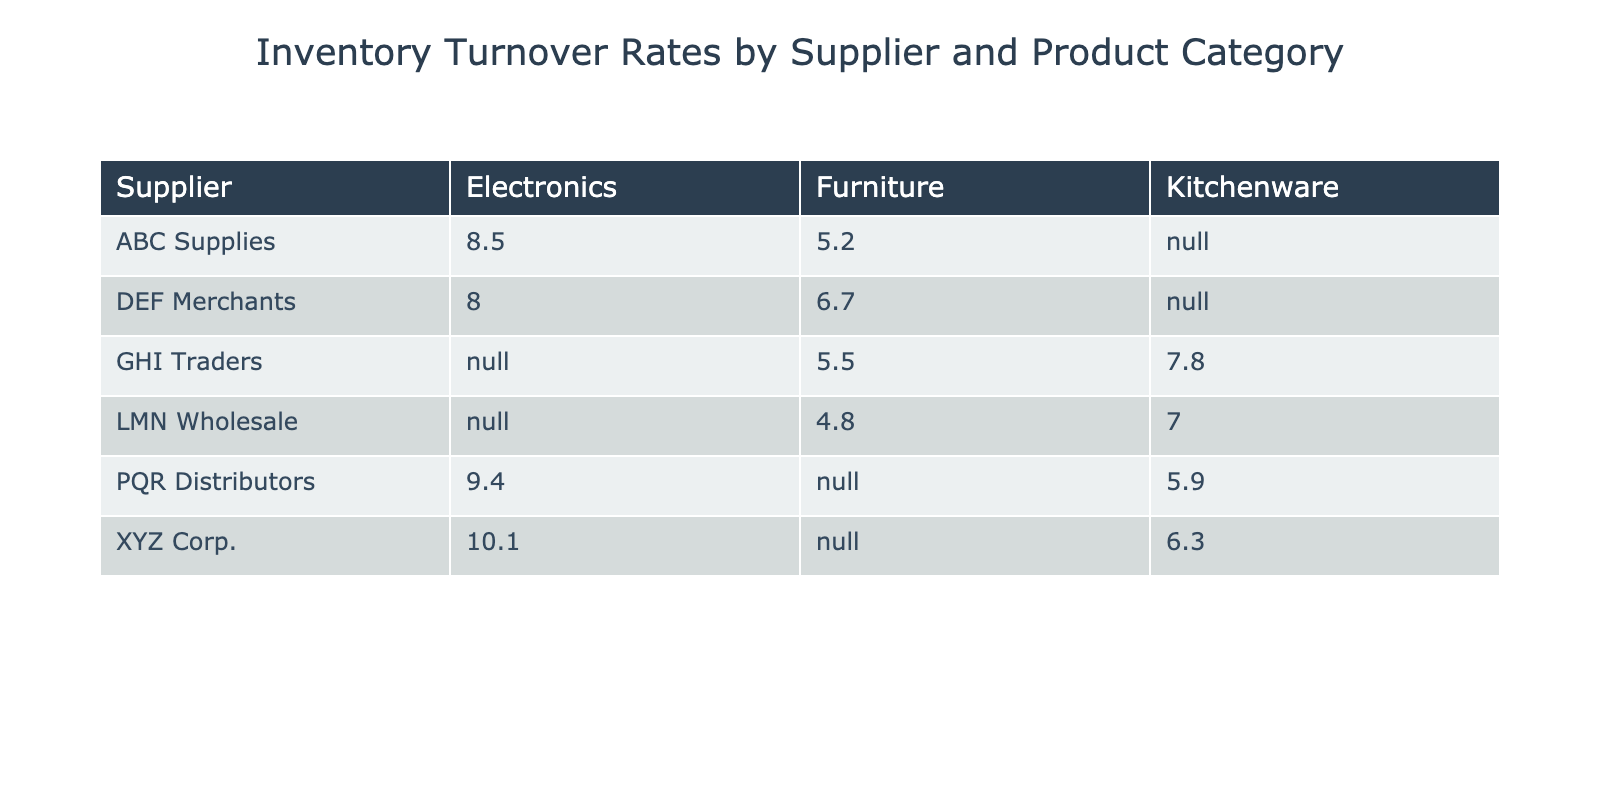What is the inventory turnover rate for ABC Supplies in the Electronics category? From the table, we can find that under the supplier "ABC Supplies," the value in the "Electronics" category is directly listed as 8.5
Answer: 8.5 Which product category has the highest inventory turnover rate for XYZ Corp.? Looking at the row for "XYZ Corp.," we see two categories: Electronics with a turnover rate of 10.1 and Kitchenware with a rate of 6.3. The higher value is 10.1 in the Electronics category
Answer: Electronics How many suppliers have a turnover rate greater than 8 in the Electronics category? By examining the "Electronics" column, we can see that the suppliers with turnover rates over 8 are ABC Supplies (8.5), XYZ Corp. (10.1), and PQR Distributors (9.4). Therefore, there are three suppliers
Answer: 3 What is the average inventory turnover rate for the Kitchenware category? The turnover rates for Kitchenware are 6.3 (XYZ Corp.), 7.0 (LMN Wholesale), 5.9 (PQR Distributors), and 7.8 (GHI Traders). Adding these gives us 6.3 + 7.0 + 5.9 + 7.8 = 27.0. Since there are 4 suppliers, the average is 27.0 / 4 = 6.75
Answer: 6.75 Is it true that DEF Merchants have a higher inventory turnover rate in Furniture than GHI Traders? Looking at DEF Merchants, their turnover rate in Furniture is 6.7. For GHI Traders, the rate is 5.5 in the same category. Since 6.7 is greater than 5.5, the statement is true
Answer: Yes Which supplier has the lowest inventory turnover rate in the Furniture category? Observing the Furniture category, we see the rates: ABC Supplies (5.2), LMN Wholesale (4.8), DEF Merchants (6.7), and GHI Traders (5.5). The lowest value is found for LMN Wholesale at 4.8
Answer: LMN Wholesale How much higher is the inventory turnover rate for PQR Distributors in Electronics compared to Kitchenware? The turnover rate for PQR Distributors in Electronics is 9.4 and in Kitchenware it is 5.9. To find the difference, we subtract 5.9 from 9.4: 9.4 - 5.9 = 3.5
Answer: 3.5 What is the most common product category among suppliers with an inventory turnover rate of at least 7? Suppliers with rates of 7 or more are ABC Supplies (Electronics, Furniture), XYZ Corp. (Electronics), LMN Wholesale (Kitchenware), PQR Distributors (Electronics), DEF Merchants (Electronics), and GHI Traders (Kitchenware). The categories showing up in this group are Electronics and Kitchenware. The category Electronics appears the most frequently
Answer: Electronics Which supplier has a turnover rate of 5.2 in the Furniture category? From the table, we can see that "ABC Supplies" is listed with a turnover rate of 5.2 in the Furniture category
Answer: ABC Supplies 